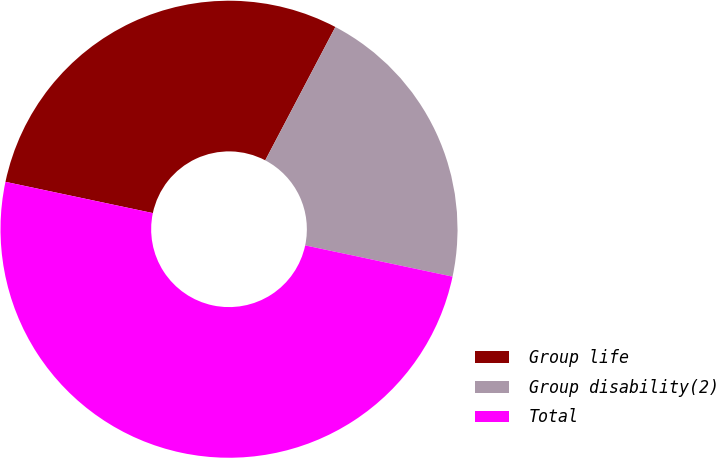<chart> <loc_0><loc_0><loc_500><loc_500><pie_chart><fcel>Group life<fcel>Group disability(2)<fcel>Total<nl><fcel>29.38%<fcel>20.62%<fcel>50.0%<nl></chart> 